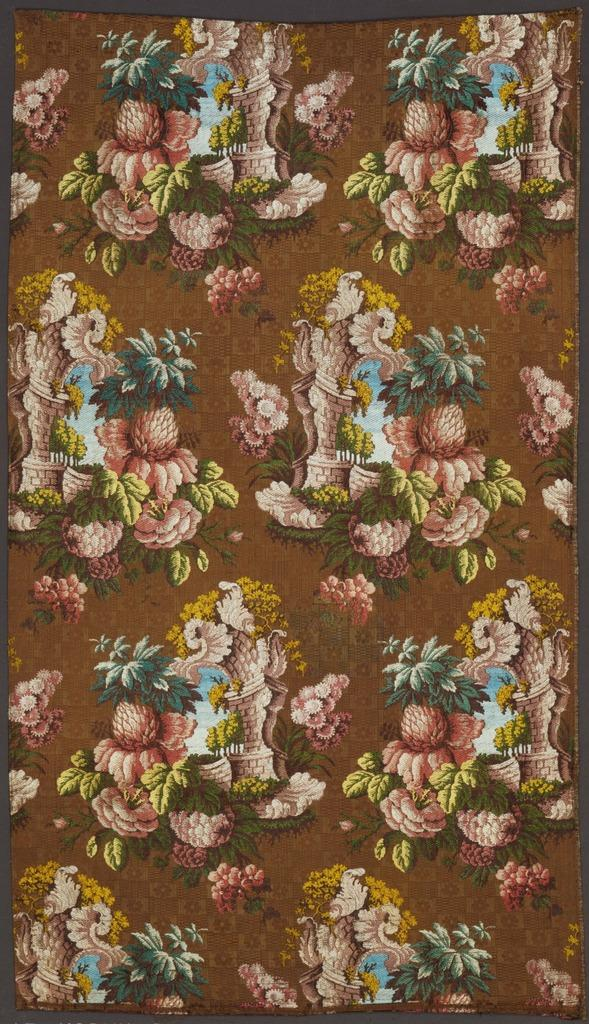What is the main object in the image? There is a photo frame in the image. What color is the background of the photo frame? The background of the photo frame is brown in color. What can be seen inside the photo frame? There are different objects present in the photo frame. How do the fairies transport themselves in the image? There are no fairies present in the image, so it is not possible to determine how they might transport themselves. 